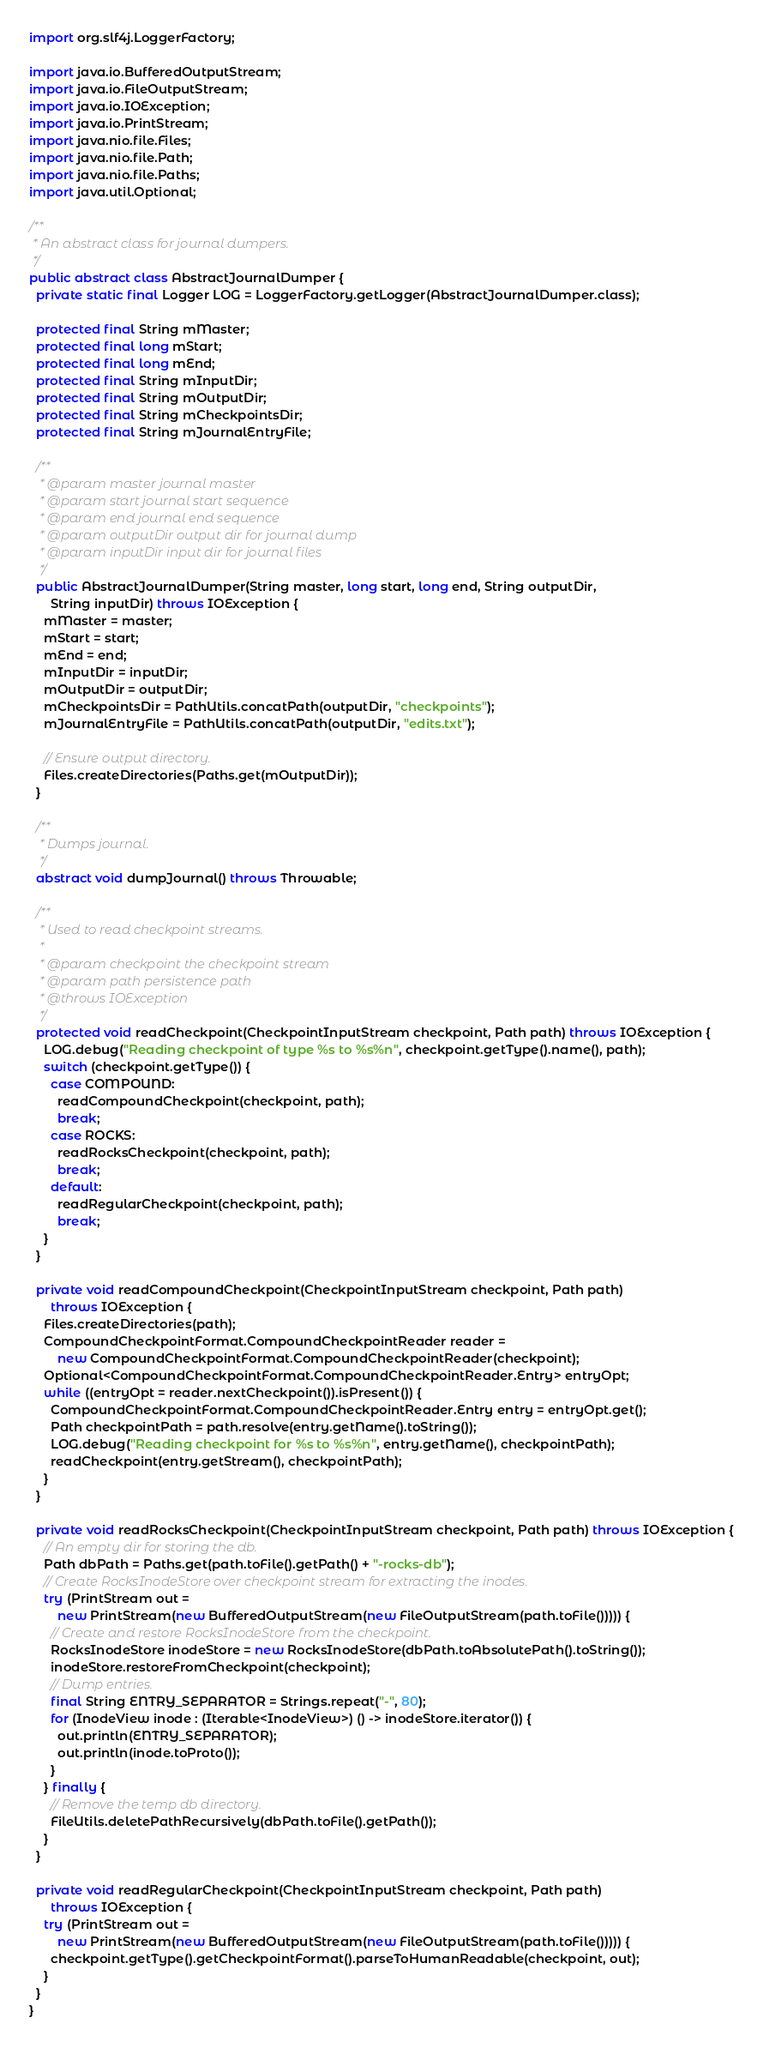Convert code to text. <code><loc_0><loc_0><loc_500><loc_500><_Java_>import org.slf4j.LoggerFactory;

import java.io.BufferedOutputStream;
import java.io.FileOutputStream;
import java.io.IOException;
import java.io.PrintStream;
import java.nio.file.Files;
import java.nio.file.Path;
import java.nio.file.Paths;
import java.util.Optional;

/**
 * An abstract class for journal dumpers.
 */
public abstract class AbstractJournalDumper {
  private static final Logger LOG = LoggerFactory.getLogger(AbstractJournalDumper.class);

  protected final String mMaster;
  protected final long mStart;
  protected final long mEnd;
  protected final String mInputDir;
  protected final String mOutputDir;
  protected final String mCheckpointsDir;
  protected final String mJournalEntryFile;

  /**
   * @param master journal master
   * @param start journal start sequence
   * @param end journal end sequence
   * @param outputDir output dir for journal dump
   * @param inputDir input dir for journal files
   */
  public AbstractJournalDumper(String master, long start, long end, String outputDir,
      String inputDir) throws IOException {
    mMaster = master;
    mStart = start;
    mEnd = end;
    mInputDir = inputDir;
    mOutputDir = outputDir;
    mCheckpointsDir = PathUtils.concatPath(outputDir, "checkpoints");
    mJournalEntryFile = PathUtils.concatPath(outputDir, "edits.txt");

    // Ensure output directory.
    Files.createDirectories(Paths.get(mOutputDir));
  }

  /**
   * Dumps journal.
   */
  abstract void dumpJournal() throws Throwable;

  /**
   * Used to read checkpoint streams.
   *
   * @param checkpoint the checkpoint stream
   * @param path persistence path
   * @throws IOException
   */
  protected void readCheckpoint(CheckpointInputStream checkpoint, Path path) throws IOException {
    LOG.debug("Reading checkpoint of type %s to %s%n", checkpoint.getType().name(), path);
    switch (checkpoint.getType()) {
      case COMPOUND:
        readCompoundCheckpoint(checkpoint, path);
        break;
      case ROCKS:
        readRocksCheckpoint(checkpoint, path);
        break;
      default:
        readRegularCheckpoint(checkpoint, path);
        break;
    }
  }

  private void readCompoundCheckpoint(CheckpointInputStream checkpoint, Path path)
      throws IOException {
    Files.createDirectories(path);
    CompoundCheckpointFormat.CompoundCheckpointReader reader =
        new CompoundCheckpointFormat.CompoundCheckpointReader(checkpoint);
    Optional<CompoundCheckpointFormat.CompoundCheckpointReader.Entry> entryOpt;
    while ((entryOpt = reader.nextCheckpoint()).isPresent()) {
      CompoundCheckpointFormat.CompoundCheckpointReader.Entry entry = entryOpt.get();
      Path checkpointPath = path.resolve(entry.getName().toString());
      LOG.debug("Reading checkpoint for %s to %s%n", entry.getName(), checkpointPath);
      readCheckpoint(entry.getStream(), checkpointPath);
    }
  }

  private void readRocksCheckpoint(CheckpointInputStream checkpoint, Path path) throws IOException {
    // An empty dir for storing the db.
    Path dbPath = Paths.get(path.toFile().getPath() + "-rocks-db");
    // Create RocksInodeStore over checkpoint stream for extracting the inodes.
    try (PrintStream out =
        new PrintStream(new BufferedOutputStream(new FileOutputStream(path.toFile())))) {
      // Create and restore RocksInodeStore from the checkpoint.
      RocksInodeStore inodeStore = new RocksInodeStore(dbPath.toAbsolutePath().toString());
      inodeStore.restoreFromCheckpoint(checkpoint);
      // Dump entries.
      final String ENTRY_SEPARATOR = Strings.repeat("-", 80);
      for (InodeView inode : (Iterable<InodeView>) () -> inodeStore.iterator()) {
        out.println(ENTRY_SEPARATOR);
        out.println(inode.toProto());
      }
    } finally {
      // Remove the temp db directory.
      FileUtils.deletePathRecursively(dbPath.toFile().getPath());
    }
  }

  private void readRegularCheckpoint(CheckpointInputStream checkpoint, Path path)
      throws IOException {
    try (PrintStream out =
        new PrintStream(new BufferedOutputStream(new FileOutputStream(path.toFile())))) {
      checkpoint.getType().getCheckpointFormat().parseToHumanReadable(checkpoint, out);
    }
  }
}
</code> 